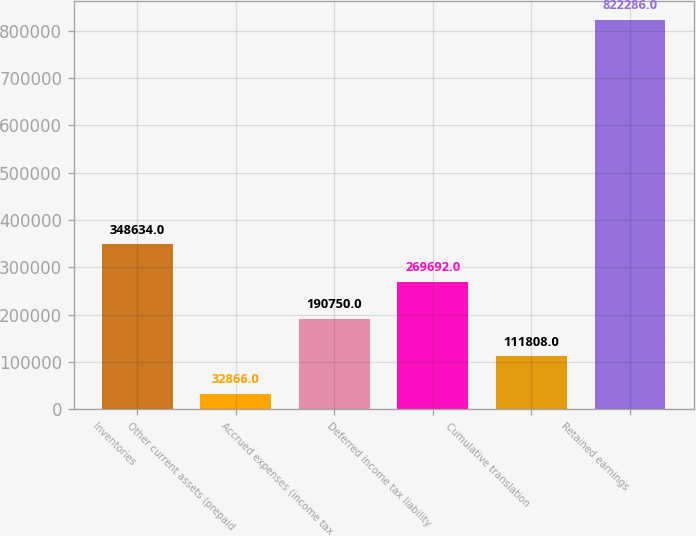<chart> <loc_0><loc_0><loc_500><loc_500><bar_chart><fcel>Inventories<fcel>Other current assets (prepaid<fcel>Accrued expenses (income tax<fcel>Deferred income tax liability<fcel>Cumulative translation<fcel>Retained earnings<nl><fcel>348634<fcel>32866<fcel>190750<fcel>269692<fcel>111808<fcel>822286<nl></chart> 